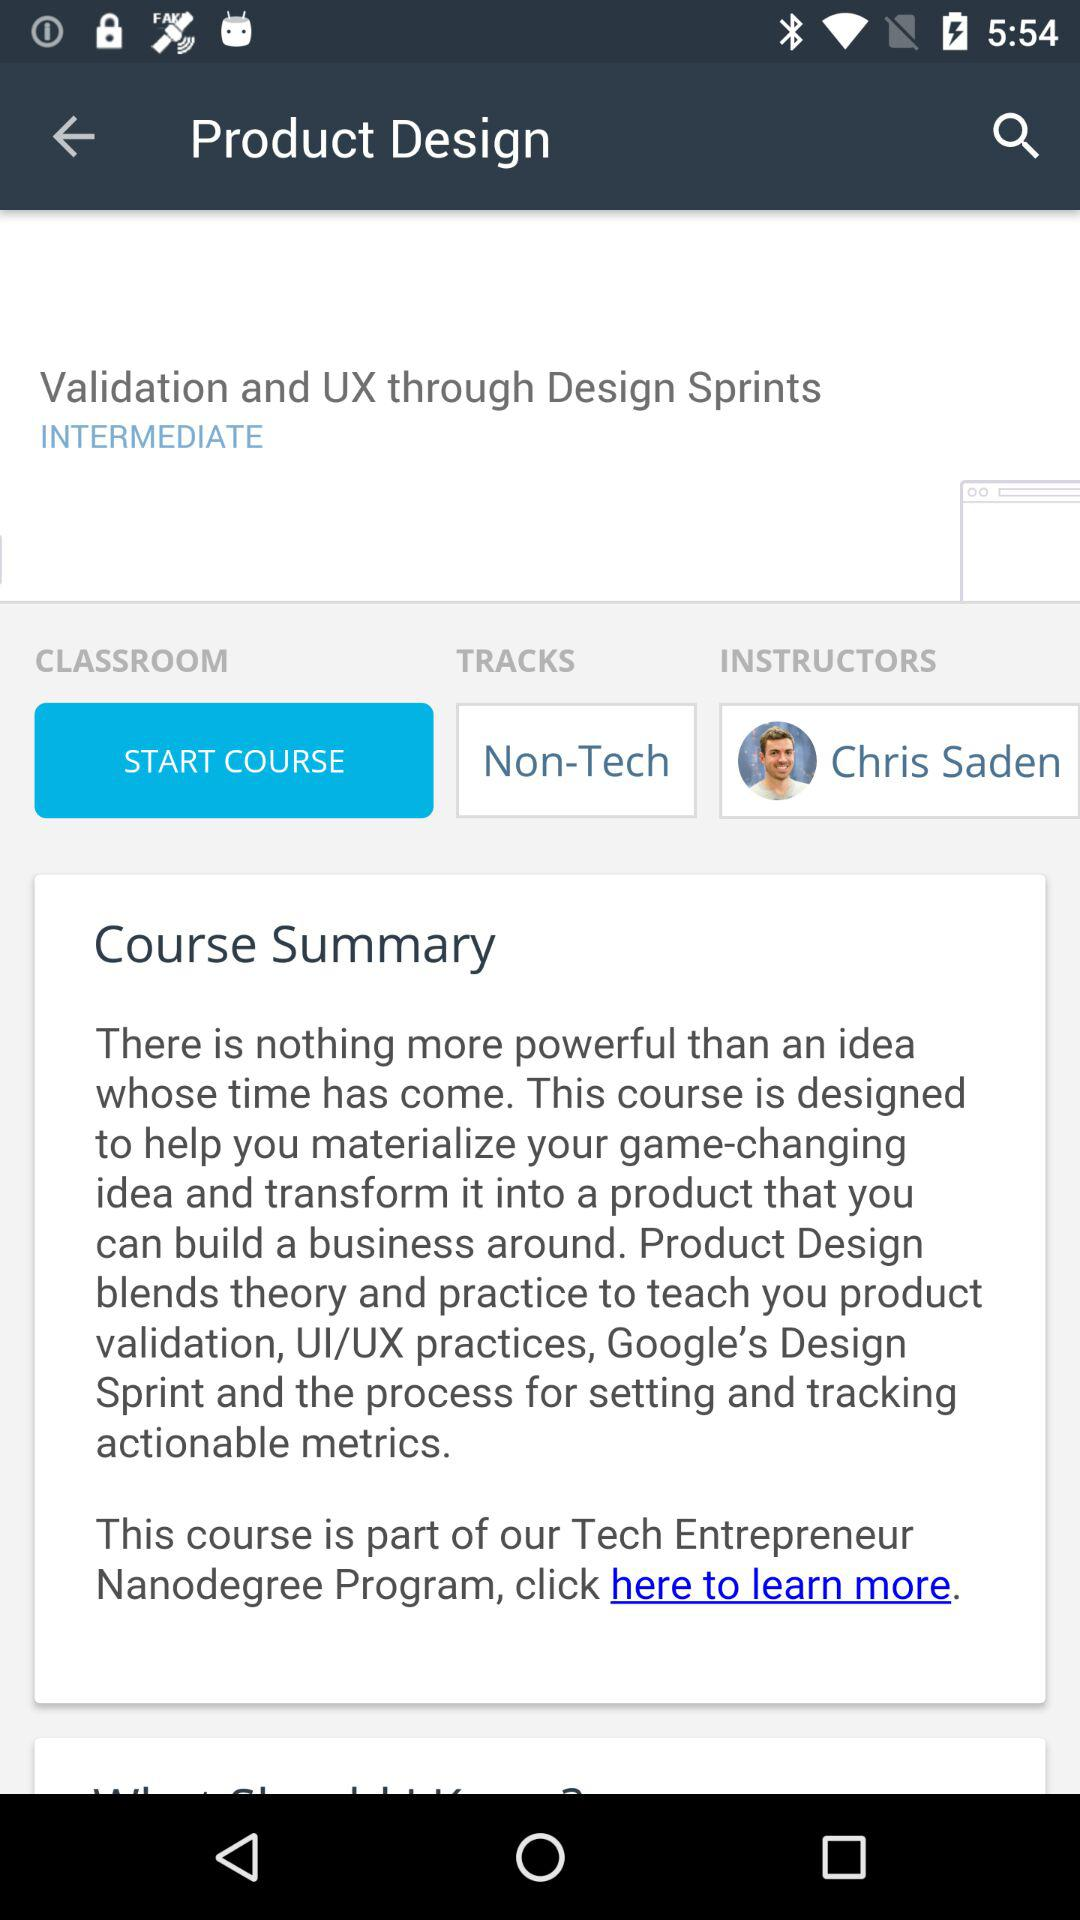How much does this course cost?
When the provided information is insufficient, respond with <no answer>. <no answer> 